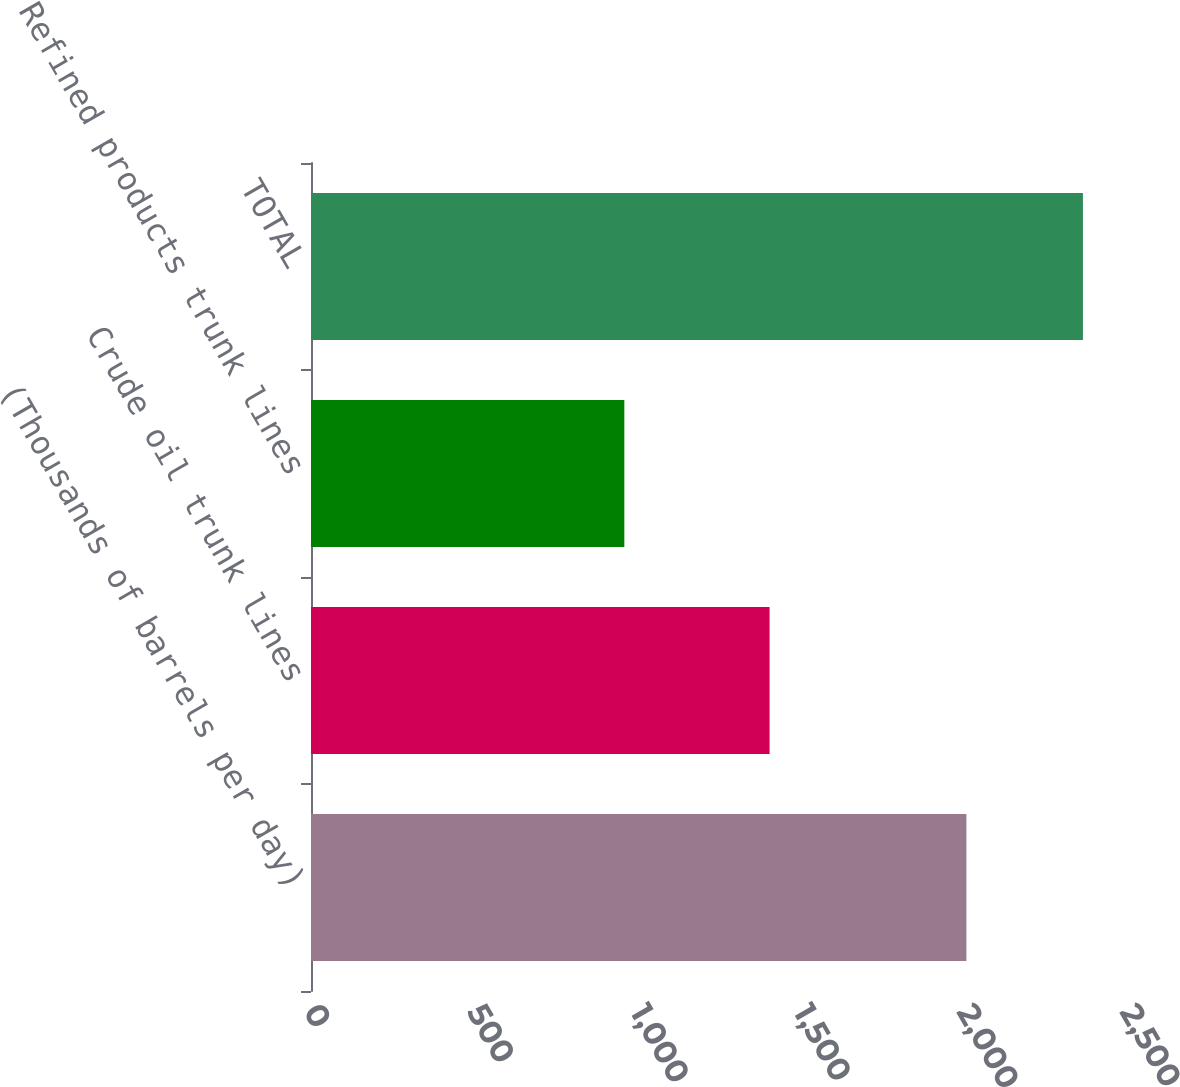Convert chart to OTSL. <chart><loc_0><loc_0><loc_500><loc_500><bar_chart><fcel>(Thousands of barrels per day)<fcel>Crude oil trunk lines<fcel>Refined products trunk lines<fcel>TOTAL<nl><fcel>2008<fcel>1405<fcel>960<fcel>2365<nl></chart> 